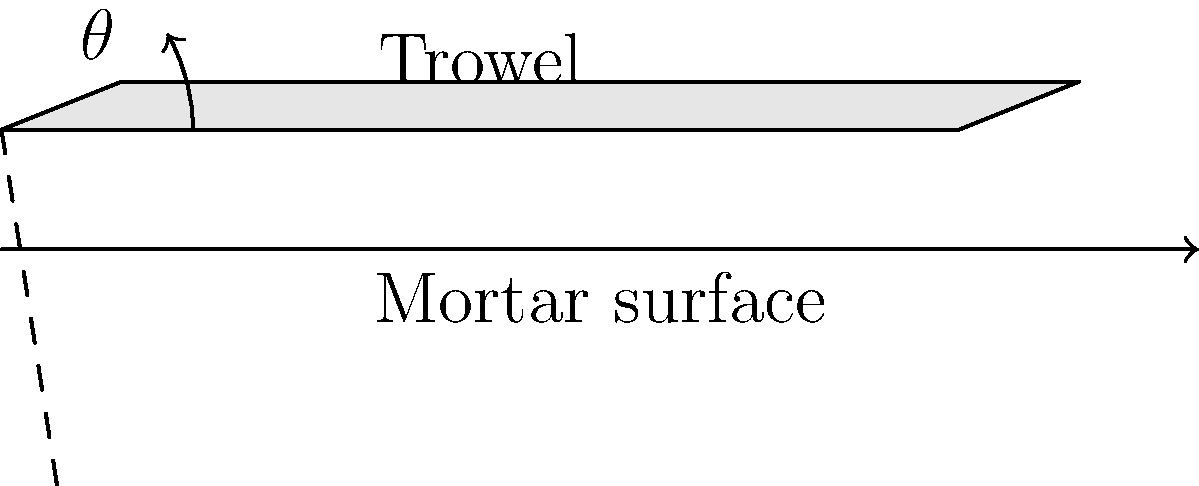In Masonic construction, what is the optimal angle $\theta$ for a trowel to spread mortar evenly, considering both the flow of the mortar and the comfort of the mason's wrist? To determine the optimal angle for a trowel to spread mortar evenly in Masonic construction, we need to consider several factors:

1. Mortar flow: The angle should allow for smooth flow of mortar from the trowel to the surface.
2. Even distribution: The angle should enable uniform spreading of mortar.
3. Wrist comfort: The angle should minimize strain on the mason's wrist during prolonged use.
4. Masonic symbolism: The angle may have symbolic significance in Freemasonry.

Considering these factors:

1. A shallow angle (close to 0°) would not allow proper control of mortar flow.
2. A steep angle (close to 90°) would cause uneven distribution and wrist strain.
3. In Masonic symbolism, the number 3 and its multiples are significant.

The optimal angle that balances these considerations is 30°. This angle:

- Allows for controlled mortar flow
- Enables even distribution of mortar
- Provides a comfortable working position for the mason's wrist
- Represents a multiple of 3, which has symbolic importance in Freemasonry

Additionally, 30° is one-third of a right angle (90°), which further emphasizes its Masonic significance as it relates to the concept of the "perfect ashlar" in Masonic symbolism.
Answer: 30° 